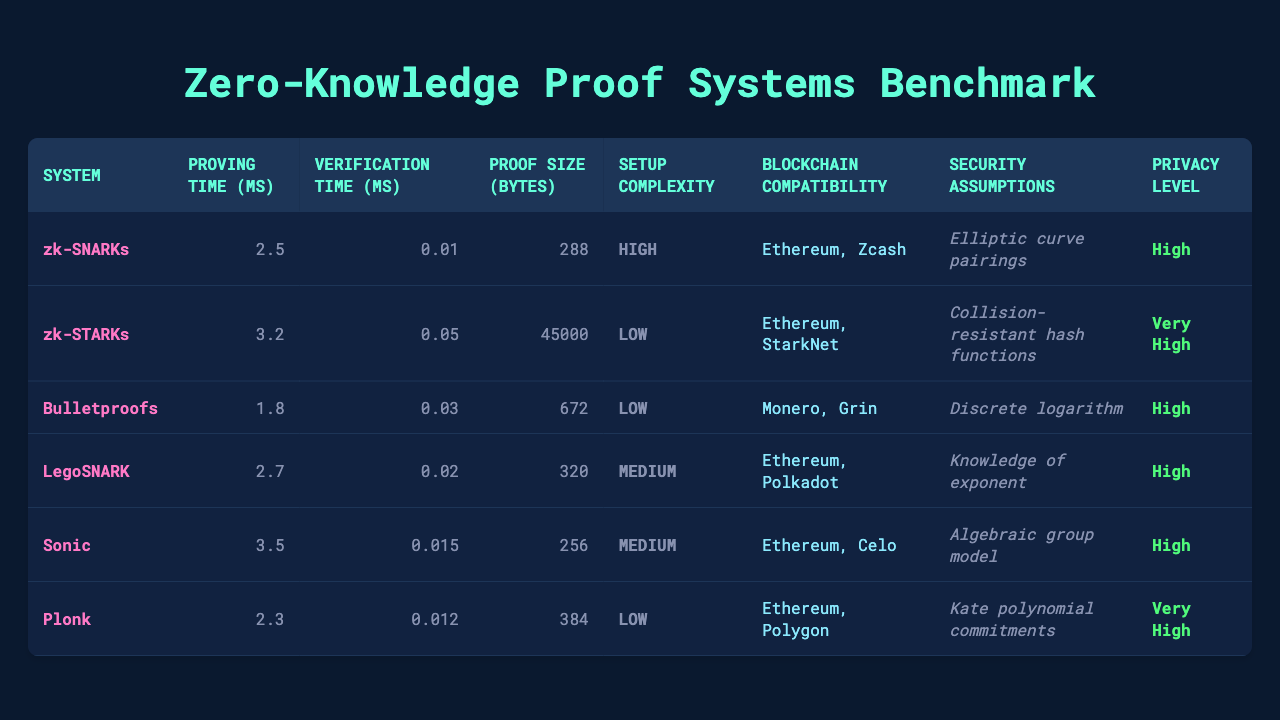What's the proof size of zk-SNARKs? The proof size for zk-SNARKs is specified in the table under the "Proof Size (bytes)" column, which shows a value of 288 bytes.
Answer: 288 bytes What is the verification time of Bulletproofs? The verification time can be found in the table in the "Verification Time (ms)" column for Bulletproofs, which indicates a value of 0.03 ms.
Answer: 0.03 ms Which zero-knowledge proof system has the highest proving time? To find the highest proving time, we compare the values in the "Proving Time (ms)" column. The highest value is 3.5 ms for Sonic.
Answer: Sonic What is the average proving time for all systems? The proving times are: 2.5, 3.2, 1.8, 2.7, 3.5, and 2.3 ms. Summing these values gives 15.0 ms. Dividing by 6 (the number of systems) gives an average of 2.5 ms.
Answer: 2.5 ms Does zk-STARKs have a low setup complexity? Looking in the table under "Setup Complexity," zk-STARKs is labeled as having "Low" complexity. Therefore, the fact is True.
Answer: True Which system has the lowest proof size? By reviewing the "Proof Size (bytes)" values, the lowest is 256 bytes for Sonic.
Answer: Sonic Is the security assumption for LegoSNARKs based on elliptic curve pairings? The "Security Assumptions" column shows that LegoSNARKs are based on "Knowledge of exponent," not elliptic curve pairings. Thus, the statement is False.
Answer: False What is the difference in proven time between the fastest and slowest systems? The fastest system is Bulletproofs with 1.8 ms, and the slowest system is Sonic with 3.5 ms. The difference is 3.5 - 1.8 = 1.7 ms.
Answer: 1.7 ms Which proof system has the highest privacy level? By comparing the "Privacy Level" column, zk-STARKs and Plonk both indicate "Very High" privacy, making them the highest.
Answer: zk-STARKs and Plonk How many systems are compatible with Ethereum? The table indicates that zk-SNARKs, zk-STARKs, LegoSNARK, Sonic, and Plonk are compatible with Ethereum. Counting them gives a total of 5 systems.
Answer: 5 systems 